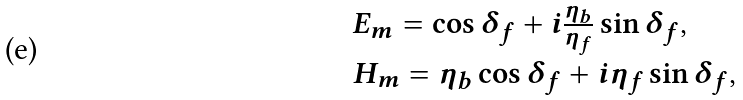Convert formula to latex. <formula><loc_0><loc_0><loc_500><loc_500>\begin{array} { l } E _ { m } = \cos \delta _ { f } + i \frac { \eta _ { b } } { \eta _ { f } } \sin \delta _ { f } , \\ H _ { m } = \eta _ { b } \cos \delta _ { f } + i \eta _ { f } \sin \delta _ { f } , \end{array}</formula> 